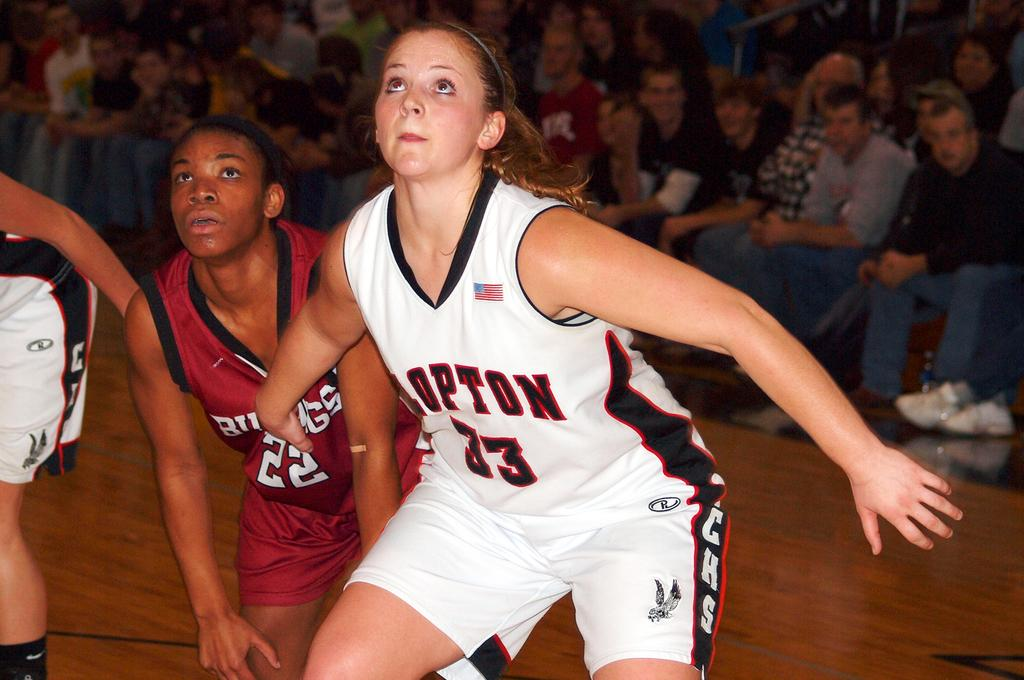<image>
Give a short and clear explanation of the subsequent image. A woman playing basketball wearing a white jersey that says opton 